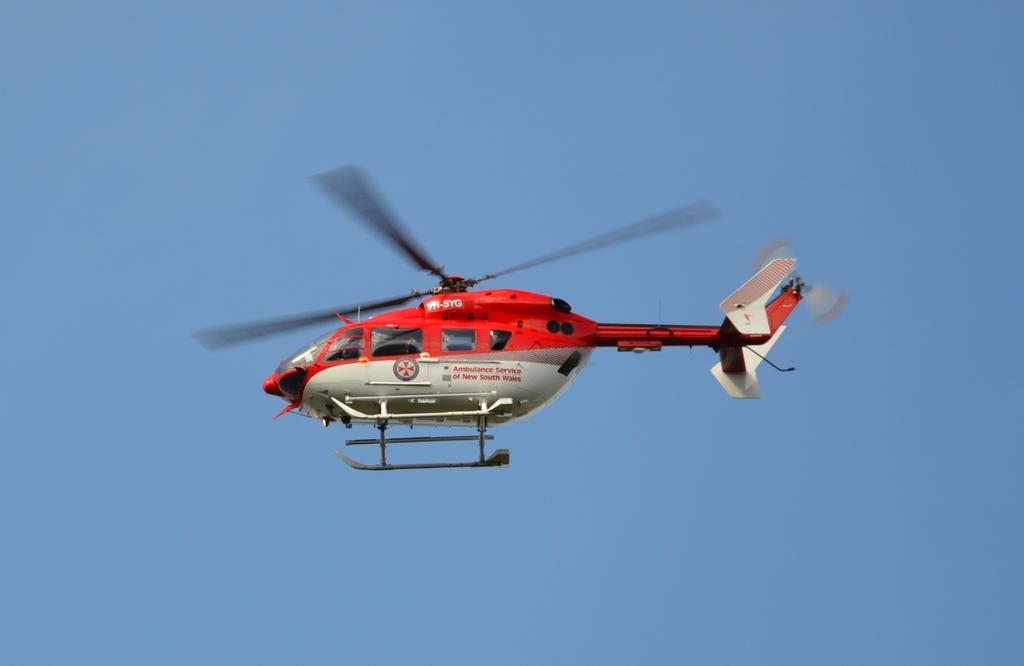How would you summarize this image in a sentence or two? Here we can see a helicopter flying in the sky. 